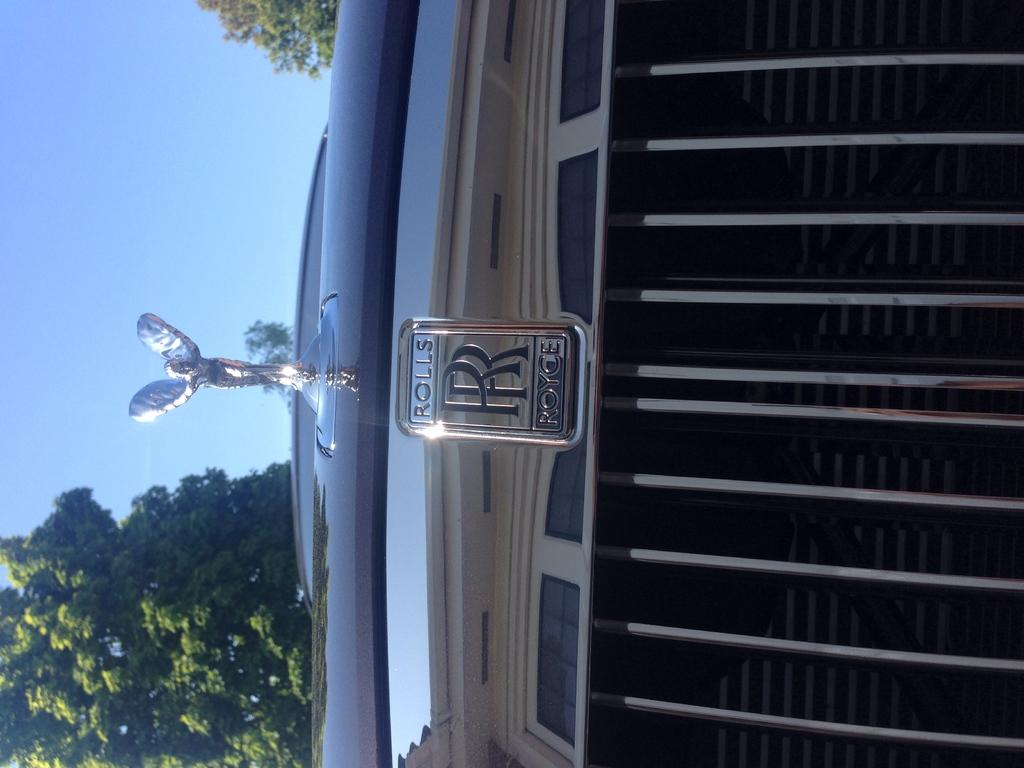What is located in the center of the image? There is text and a logo in the center of the image. What else can be seen in the center of the image? There is a sculpture on the vehicle in the center of the image. What is visible on the left side of the image? There are trees on the left side of the image. What is visible in the background of the image? The sky is visible in the image. What type of ink is used to write the text in the image? There is no information about the type of ink used in the image, as the focus is on the text and logo being present. Can you see anyone walking in the image? There is no indication of anyone walking in the image; the focus is on the text, logo, sculpture, trees, and sky. 